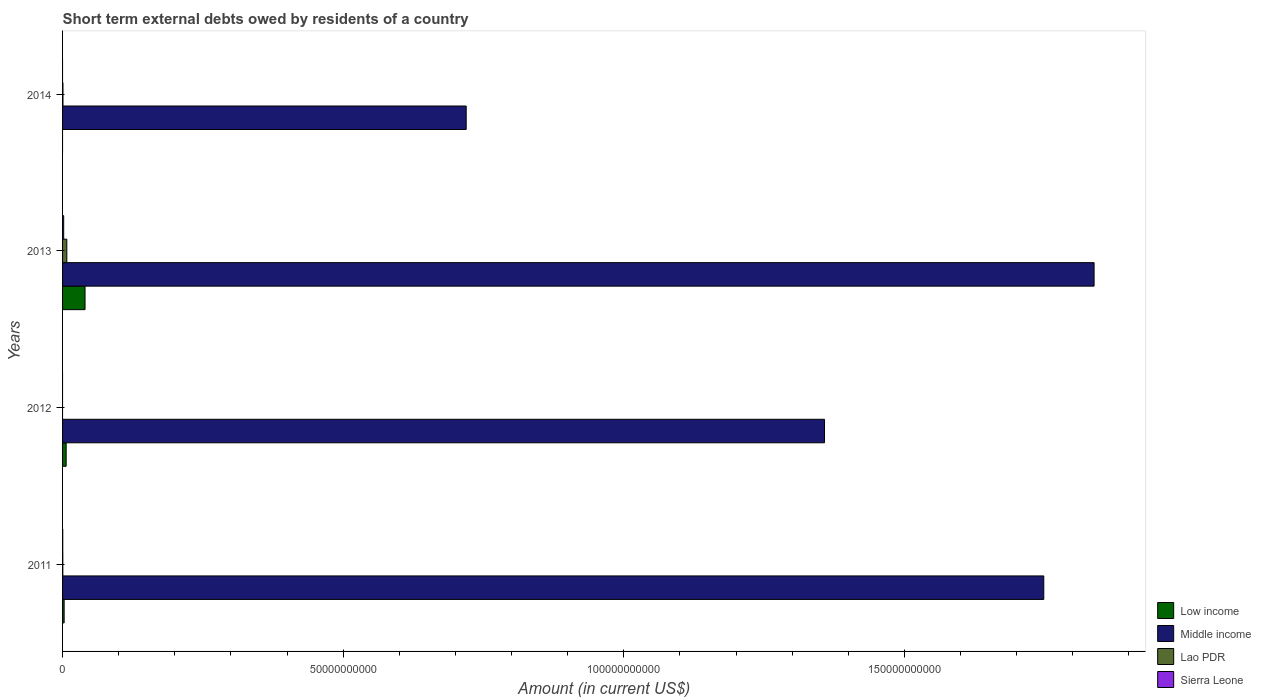How many different coloured bars are there?
Your answer should be very brief. 4. How many groups of bars are there?
Offer a very short reply. 4. Are the number of bars per tick equal to the number of legend labels?
Ensure brevity in your answer.  No. Are the number of bars on each tick of the Y-axis equal?
Make the answer very short. No. How many bars are there on the 2nd tick from the top?
Your answer should be very brief. 4. How many bars are there on the 1st tick from the bottom?
Your response must be concise. 4. In how many cases, is the number of bars for a given year not equal to the number of legend labels?
Provide a short and direct response. 2. Across all years, what is the maximum amount of short-term external debts owed by residents in Sierra Leone?
Provide a short and direct response. 2.00e+08. Across all years, what is the minimum amount of short-term external debts owed by residents in Low income?
Provide a short and direct response. 0. In which year was the amount of short-term external debts owed by residents in Low income maximum?
Your response must be concise. 2013. What is the total amount of short-term external debts owed by residents in Lao PDR in the graph?
Offer a very short reply. 8.68e+08. What is the difference between the amount of short-term external debts owed by residents in Sierra Leone in 2011 and that in 2013?
Your response must be concise. -1.69e+08. What is the difference between the amount of short-term external debts owed by residents in Middle income in 2014 and the amount of short-term external debts owed by residents in Lao PDR in 2012?
Keep it short and to the point. 7.19e+1. What is the average amount of short-term external debts owed by residents in Sierra Leone per year?
Your response must be concise. 5.77e+07. In the year 2013, what is the difference between the amount of short-term external debts owed by residents in Middle income and amount of short-term external debts owed by residents in Lao PDR?
Offer a terse response. 1.83e+11. What is the ratio of the amount of short-term external debts owed by residents in Middle income in 2011 to that in 2012?
Your response must be concise. 1.29. What is the difference between the highest and the second highest amount of short-term external debts owed by residents in Middle income?
Provide a short and direct response. 8.96e+09. What is the difference between the highest and the lowest amount of short-term external debts owed by residents in Sierra Leone?
Give a very brief answer. 2.00e+08. Is it the case that in every year, the sum of the amount of short-term external debts owed by residents in Sierra Leone and amount of short-term external debts owed by residents in Middle income is greater than the sum of amount of short-term external debts owed by residents in Low income and amount of short-term external debts owed by residents in Lao PDR?
Ensure brevity in your answer.  Yes. Is it the case that in every year, the sum of the amount of short-term external debts owed by residents in Low income and amount of short-term external debts owed by residents in Lao PDR is greater than the amount of short-term external debts owed by residents in Middle income?
Make the answer very short. No. Are all the bars in the graph horizontal?
Offer a terse response. Yes. What is the difference between two consecutive major ticks on the X-axis?
Offer a very short reply. 5.00e+1. Does the graph contain any zero values?
Make the answer very short. Yes. Does the graph contain grids?
Provide a succinct answer. No. Where does the legend appear in the graph?
Make the answer very short. Bottom right. How are the legend labels stacked?
Make the answer very short. Vertical. What is the title of the graph?
Offer a terse response. Short term external debts owed by residents of a country. What is the Amount (in current US$) in Low income in 2011?
Make the answer very short. 2.81e+08. What is the Amount (in current US$) in Middle income in 2011?
Your answer should be very brief. 1.75e+11. What is the Amount (in current US$) of Lao PDR in 2011?
Offer a terse response. 4.40e+07. What is the Amount (in current US$) in Sierra Leone in 2011?
Offer a very short reply. 3.10e+07. What is the Amount (in current US$) in Low income in 2012?
Keep it short and to the point. 6.38e+08. What is the Amount (in current US$) in Middle income in 2012?
Your response must be concise. 1.36e+11. What is the Amount (in current US$) in Lao PDR in 2012?
Your response must be concise. 0. What is the Amount (in current US$) in Low income in 2013?
Give a very brief answer. 4.00e+09. What is the Amount (in current US$) in Middle income in 2013?
Offer a terse response. 1.84e+11. What is the Amount (in current US$) of Lao PDR in 2013?
Provide a succinct answer. 7.56e+08. What is the Amount (in current US$) in Sierra Leone in 2013?
Offer a very short reply. 2.00e+08. What is the Amount (in current US$) in Low income in 2014?
Provide a short and direct response. 0. What is the Amount (in current US$) in Middle income in 2014?
Your answer should be compact. 7.19e+1. What is the Amount (in current US$) in Lao PDR in 2014?
Ensure brevity in your answer.  6.80e+07. What is the Amount (in current US$) in Sierra Leone in 2014?
Offer a terse response. 0. Across all years, what is the maximum Amount (in current US$) of Low income?
Give a very brief answer. 4.00e+09. Across all years, what is the maximum Amount (in current US$) of Middle income?
Keep it short and to the point. 1.84e+11. Across all years, what is the maximum Amount (in current US$) in Lao PDR?
Ensure brevity in your answer.  7.56e+08. Across all years, what is the maximum Amount (in current US$) in Sierra Leone?
Your answer should be compact. 2.00e+08. Across all years, what is the minimum Amount (in current US$) of Middle income?
Your answer should be compact. 7.19e+1. What is the total Amount (in current US$) in Low income in the graph?
Your response must be concise. 4.92e+09. What is the total Amount (in current US$) of Middle income in the graph?
Your answer should be compact. 5.66e+11. What is the total Amount (in current US$) of Lao PDR in the graph?
Offer a very short reply. 8.68e+08. What is the total Amount (in current US$) in Sierra Leone in the graph?
Your answer should be compact. 2.31e+08. What is the difference between the Amount (in current US$) in Low income in 2011 and that in 2012?
Your response must be concise. -3.57e+08. What is the difference between the Amount (in current US$) of Middle income in 2011 and that in 2012?
Your response must be concise. 3.91e+1. What is the difference between the Amount (in current US$) of Low income in 2011 and that in 2013?
Provide a short and direct response. -3.72e+09. What is the difference between the Amount (in current US$) in Middle income in 2011 and that in 2013?
Your answer should be compact. -8.96e+09. What is the difference between the Amount (in current US$) in Lao PDR in 2011 and that in 2013?
Offer a very short reply. -7.12e+08. What is the difference between the Amount (in current US$) in Sierra Leone in 2011 and that in 2013?
Your answer should be very brief. -1.69e+08. What is the difference between the Amount (in current US$) in Middle income in 2011 and that in 2014?
Keep it short and to the point. 1.03e+11. What is the difference between the Amount (in current US$) of Lao PDR in 2011 and that in 2014?
Offer a terse response. -2.40e+07. What is the difference between the Amount (in current US$) of Low income in 2012 and that in 2013?
Offer a terse response. -3.37e+09. What is the difference between the Amount (in current US$) of Middle income in 2012 and that in 2013?
Your answer should be very brief. -4.80e+1. What is the difference between the Amount (in current US$) of Middle income in 2012 and that in 2014?
Provide a short and direct response. 6.38e+1. What is the difference between the Amount (in current US$) of Middle income in 2013 and that in 2014?
Keep it short and to the point. 1.12e+11. What is the difference between the Amount (in current US$) of Lao PDR in 2013 and that in 2014?
Your answer should be compact. 6.88e+08. What is the difference between the Amount (in current US$) of Low income in 2011 and the Amount (in current US$) of Middle income in 2012?
Your response must be concise. -1.35e+11. What is the difference between the Amount (in current US$) in Low income in 2011 and the Amount (in current US$) in Middle income in 2013?
Your response must be concise. -1.84e+11. What is the difference between the Amount (in current US$) of Low income in 2011 and the Amount (in current US$) of Lao PDR in 2013?
Your response must be concise. -4.75e+08. What is the difference between the Amount (in current US$) of Low income in 2011 and the Amount (in current US$) of Sierra Leone in 2013?
Offer a terse response. 8.13e+07. What is the difference between the Amount (in current US$) in Middle income in 2011 and the Amount (in current US$) in Lao PDR in 2013?
Ensure brevity in your answer.  1.74e+11. What is the difference between the Amount (in current US$) of Middle income in 2011 and the Amount (in current US$) of Sierra Leone in 2013?
Offer a very short reply. 1.75e+11. What is the difference between the Amount (in current US$) of Lao PDR in 2011 and the Amount (in current US$) of Sierra Leone in 2013?
Your answer should be compact. -1.56e+08. What is the difference between the Amount (in current US$) of Low income in 2011 and the Amount (in current US$) of Middle income in 2014?
Provide a succinct answer. -7.16e+1. What is the difference between the Amount (in current US$) in Low income in 2011 and the Amount (in current US$) in Lao PDR in 2014?
Your response must be concise. 2.13e+08. What is the difference between the Amount (in current US$) of Middle income in 2011 and the Amount (in current US$) of Lao PDR in 2014?
Provide a short and direct response. 1.75e+11. What is the difference between the Amount (in current US$) in Low income in 2012 and the Amount (in current US$) in Middle income in 2013?
Your response must be concise. -1.83e+11. What is the difference between the Amount (in current US$) of Low income in 2012 and the Amount (in current US$) of Lao PDR in 2013?
Ensure brevity in your answer.  -1.18e+08. What is the difference between the Amount (in current US$) in Low income in 2012 and the Amount (in current US$) in Sierra Leone in 2013?
Your answer should be very brief. 4.39e+08. What is the difference between the Amount (in current US$) in Middle income in 2012 and the Amount (in current US$) in Lao PDR in 2013?
Provide a short and direct response. 1.35e+11. What is the difference between the Amount (in current US$) of Middle income in 2012 and the Amount (in current US$) of Sierra Leone in 2013?
Offer a terse response. 1.36e+11. What is the difference between the Amount (in current US$) of Low income in 2012 and the Amount (in current US$) of Middle income in 2014?
Make the answer very short. -7.13e+1. What is the difference between the Amount (in current US$) in Low income in 2012 and the Amount (in current US$) in Lao PDR in 2014?
Your answer should be very brief. 5.70e+08. What is the difference between the Amount (in current US$) in Middle income in 2012 and the Amount (in current US$) in Lao PDR in 2014?
Give a very brief answer. 1.36e+11. What is the difference between the Amount (in current US$) in Low income in 2013 and the Amount (in current US$) in Middle income in 2014?
Give a very brief answer. -6.79e+1. What is the difference between the Amount (in current US$) of Low income in 2013 and the Amount (in current US$) of Lao PDR in 2014?
Keep it short and to the point. 3.94e+09. What is the difference between the Amount (in current US$) of Middle income in 2013 and the Amount (in current US$) of Lao PDR in 2014?
Your answer should be very brief. 1.84e+11. What is the average Amount (in current US$) of Low income per year?
Keep it short and to the point. 1.23e+09. What is the average Amount (in current US$) in Middle income per year?
Make the answer very short. 1.42e+11. What is the average Amount (in current US$) in Lao PDR per year?
Your answer should be very brief. 2.17e+08. What is the average Amount (in current US$) of Sierra Leone per year?
Your answer should be compact. 5.77e+07. In the year 2011, what is the difference between the Amount (in current US$) of Low income and Amount (in current US$) of Middle income?
Offer a terse response. -1.75e+11. In the year 2011, what is the difference between the Amount (in current US$) in Low income and Amount (in current US$) in Lao PDR?
Make the answer very short. 2.37e+08. In the year 2011, what is the difference between the Amount (in current US$) in Low income and Amount (in current US$) in Sierra Leone?
Ensure brevity in your answer.  2.50e+08. In the year 2011, what is the difference between the Amount (in current US$) in Middle income and Amount (in current US$) in Lao PDR?
Provide a short and direct response. 1.75e+11. In the year 2011, what is the difference between the Amount (in current US$) in Middle income and Amount (in current US$) in Sierra Leone?
Offer a terse response. 1.75e+11. In the year 2011, what is the difference between the Amount (in current US$) in Lao PDR and Amount (in current US$) in Sierra Leone?
Provide a short and direct response. 1.30e+07. In the year 2012, what is the difference between the Amount (in current US$) of Low income and Amount (in current US$) of Middle income?
Offer a terse response. -1.35e+11. In the year 2013, what is the difference between the Amount (in current US$) in Low income and Amount (in current US$) in Middle income?
Provide a succinct answer. -1.80e+11. In the year 2013, what is the difference between the Amount (in current US$) of Low income and Amount (in current US$) of Lao PDR?
Offer a very short reply. 3.25e+09. In the year 2013, what is the difference between the Amount (in current US$) of Low income and Amount (in current US$) of Sierra Leone?
Provide a succinct answer. 3.80e+09. In the year 2013, what is the difference between the Amount (in current US$) of Middle income and Amount (in current US$) of Lao PDR?
Offer a very short reply. 1.83e+11. In the year 2013, what is the difference between the Amount (in current US$) in Middle income and Amount (in current US$) in Sierra Leone?
Keep it short and to the point. 1.84e+11. In the year 2013, what is the difference between the Amount (in current US$) of Lao PDR and Amount (in current US$) of Sierra Leone?
Provide a succinct answer. 5.56e+08. In the year 2014, what is the difference between the Amount (in current US$) in Middle income and Amount (in current US$) in Lao PDR?
Your response must be concise. 7.19e+1. What is the ratio of the Amount (in current US$) of Low income in 2011 to that in 2012?
Your answer should be compact. 0.44. What is the ratio of the Amount (in current US$) of Middle income in 2011 to that in 2012?
Your response must be concise. 1.29. What is the ratio of the Amount (in current US$) of Low income in 2011 to that in 2013?
Offer a very short reply. 0.07. What is the ratio of the Amount (in current US$) in Middle income in 2011 to that in 2013?
Provide a succinct answer. 0.95. What is the ratio of the Amount (in current US$) of Lao PDR in 2011 to that in 2013?
Give a very brief answer. 0.06. What is the ratio of the Amount (in current US$) of Sierra Leone in 2011 to that in 2013?
Give a very brief answer. 0.16. What is the ratio of the Amount (in current US$) of Middle income in 2011 to that in 2014?
Provide a short and direct response. 2.43. What is the ratio of the Amount (in current US$) in Lao PDR in 2011 to that in 2014?
Ensure brevity in your answer.  0.65. What is the ratio of the Amount (in current US$) of Low income in 2012 to that in 2013?
Keep it short and to the point. 0.16. What is the ratio of the Amount (in current US$) in Middle income in 2012 to that in 2013?
Provide a succinct answer. 0.74. What is the ratio of the Amount (in current US$) of Middle income in 2012 to that in 2014?
Give a very brief answer. 1.89. What is the ratio of the Amount (in current US$) in Middle income in 2013 to that in 2014?
Make the answer very short. 2.56. What is the ratio of the Amount (in current US$) of Lao PDR in 2013 to that in 2014?
Your answer should be compact. 11.12. What is the difference between the highest and the second highest Amount (in current US$) of Low income?
Keep it short and to the point. 3.37e+09. What is the difference between the highest and the second highest Amount (in current US$) in Middle income?
Your answer should be compact. 8.96e+09. What is the difference between the highest and the second highest Amount (in current US$) of Lao PDR?
Your response must be concise. 6.88e+08. What is the difference between the highest and the lowest Amount (in current US$) of Low income?
Provide a succinct answer. 4.00e+09. What is the difference between the highest and the lowest Amount (in current US$) in Middle income?
Your answer should be very brief. 1.12e+11. What is the difference between the highest and the lowest Amount (in current US$) of Lao PDR?
Keep it short and to the point. 7.56e+08. What is the difference between the highest and the lowest Amount (in current US$) in Sierra Leone?
Your answer should be very brief. 2.00e+08. 